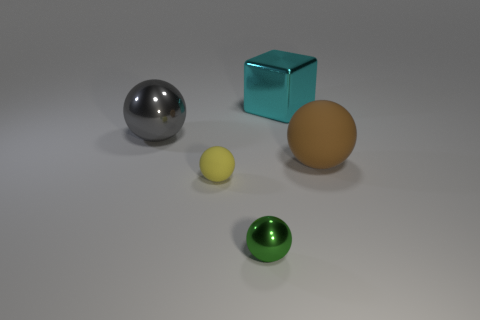Subtract all yellow matte balls. How many balls are left? 3 Add 1 green things. How many objects exist? 6 Subtract all gray spheres. How many spheres are left? 3 Subtract all spheres. How many objects are left? 1 Subtract 1 spheres. How many spheres are left? 3 Add 2 large yellow metal objects. How many large yellow metal objects exist? 2 Subtract 0 purple cylinders. How many objects are left? 5 Subtract all blue balls. Subtract all purple blocks. How many balls are left? 4 Subtract all small green matte cubes. Subtract all yellow spheres. How many objects are left? 4 Add 1 metallic balls. How many metallic balls are left? 3 